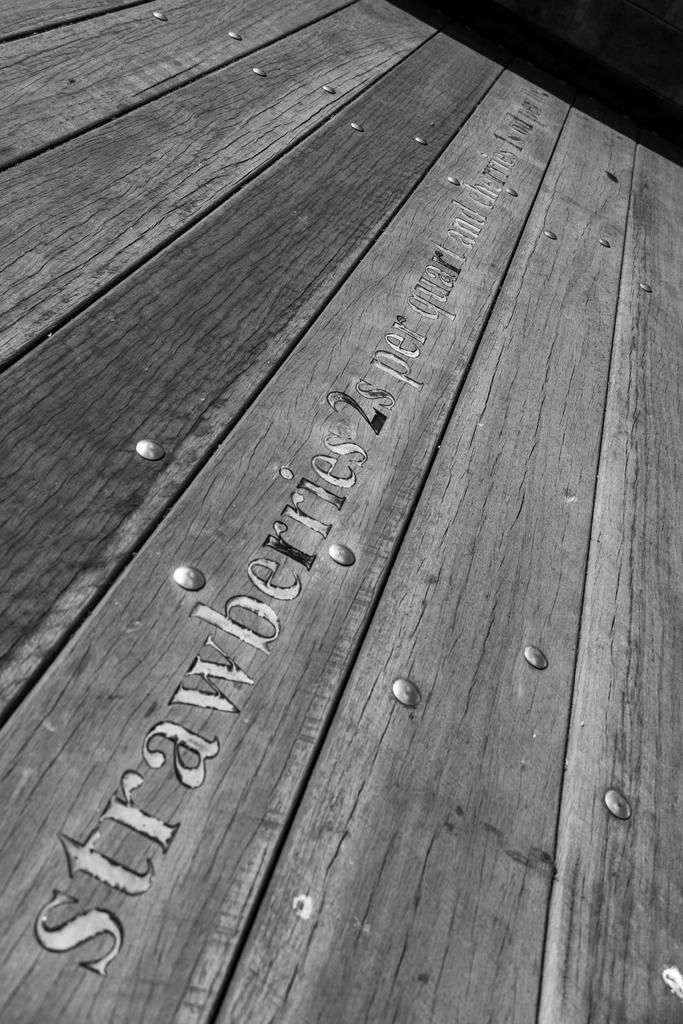<image>
Present a compact description of the photo's key features. A wooden sign has the words "strawberries 2s per quart" written on it 